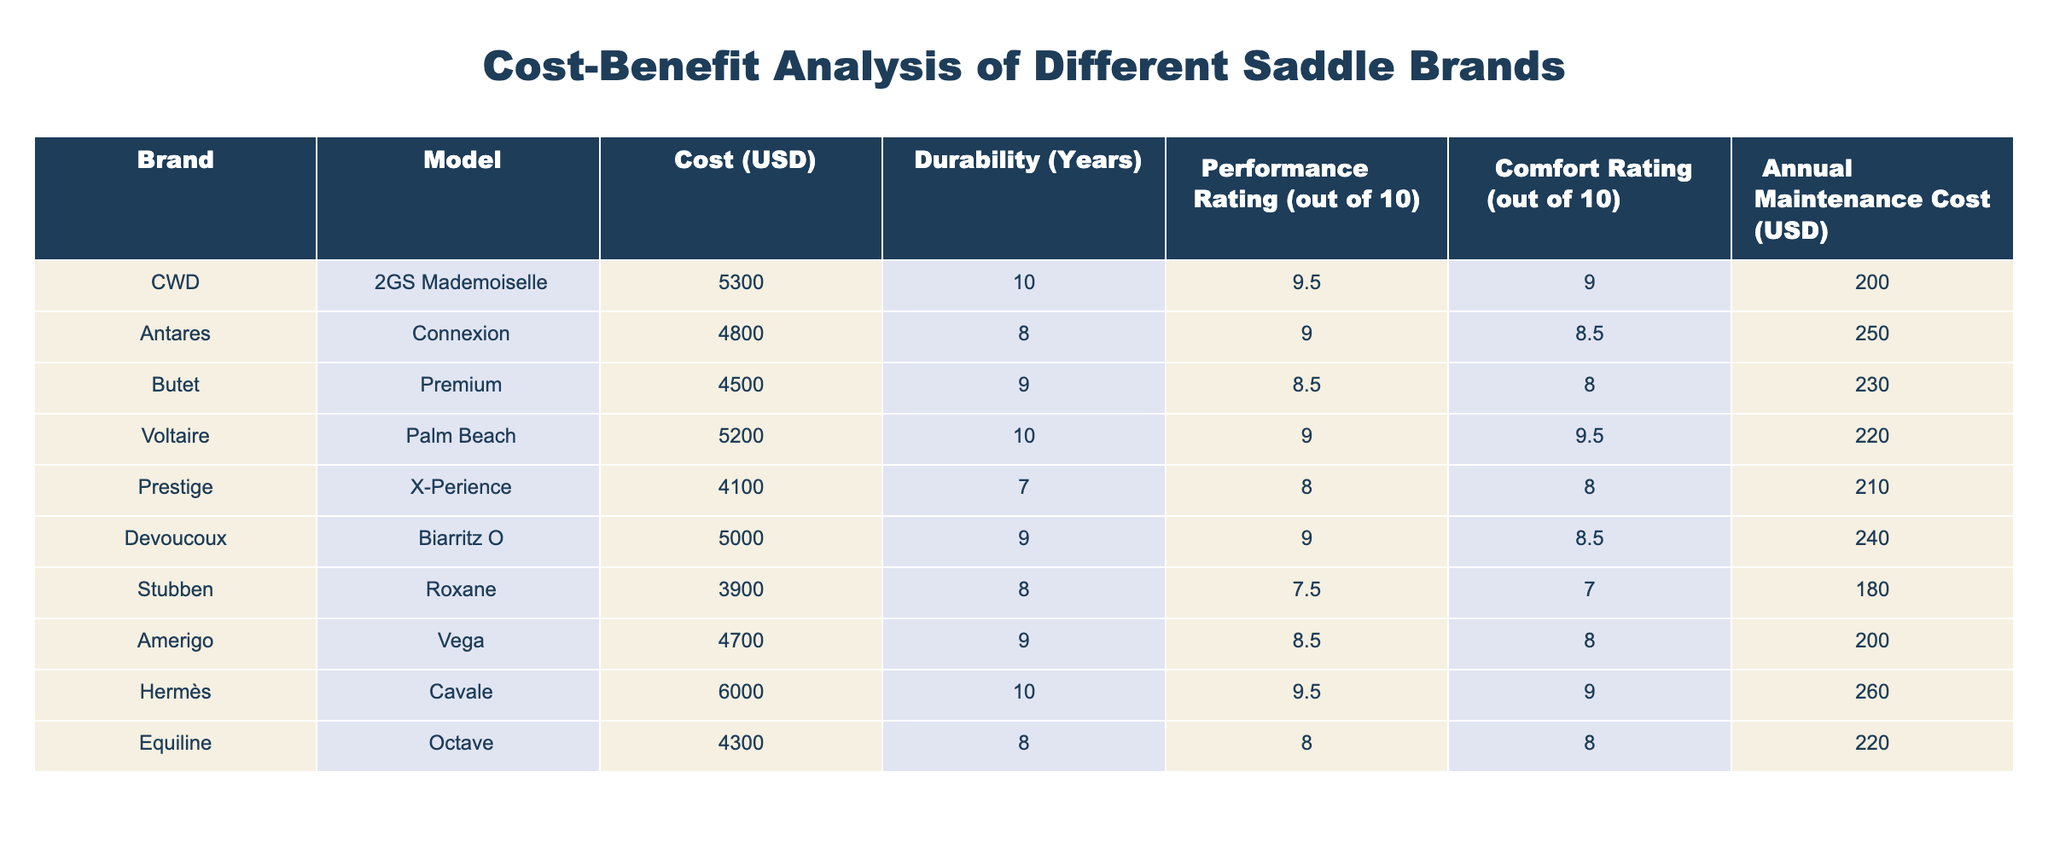What is the cost of the Butet Premium saddle? The table lists the Butet Premium under the Brand column, showing its Cost (USD) as 4500.
Answer: 4500 Which saddle has the highest comfort rating? By examining the Comfort Rating column, the CWD 2GS Mademoiselle and the Hermès Cavale both have the highest rating of 9, which is the highest among all listed saddles.
Answer: CWD 2GS Mademoiselle and Hermès Cavale What is the average annual maintenance cost of all the saddles listed? To find the average, sum the annual maintenance costs: 200 + 250 + 230 + 220 + 210 + 240 + 180 + 200 + 260 + 220 = 2,220. Then, divide by the number of saddles (10): 2,220 / 10 = 222.
Answer: 222 Is the Antares Connexion saddle more durable than the Prestige X-Perience saddle? The Antares Connexion has a durability of 8 years, whereas the Prestige X-Perience has a durability of only 7 years. Therefore, Antares Connexion is indeed more durable.
Answer: Yes Which saddle has the best performance rating for a cost lower than 5000 USD? The saddles priced under 5000 USD are the Butet Premium, Stubben Roxane, Amerigo Vega, and Prestige X-Perience. Among these, the highest performance rating is 8.5 for both the Butet Premium and Amerigo Vega; therefore, either can be selected based on the criteria.
Answer: Butet Premium and Amerigo Vega What is the total cost for maintaining the top three most expensive saddles for one year? The most expensive saddles are Hermès Cavale (260), CWD 2GS Mademoiselle (200), and Voltaire Palm Beach (220). Summing their annual maintenance costs gives us: 260 + 200 + 220 = 680.
Answer: 680 Which saddle has the lowest performance rating? By reviewing the Performance Rating column, the Stubben Roxane has the lowest rating, which is 7.5.
Answer: Stubben Roxane How many years will it take to recover the additional cost between the CWD 2GS Mademoiselle and the Stubben Roxane in terms of their annual maintenance costs? The cost difference is 5300 - 3900 = 1400. The additional annual maintenance cost for CWD is 200 - 180 = 20. To find the number of years to recover the additional cost, divide the difference by the additional maintenance cost: 1400 / 20 = 70.
Answer: 70 years 